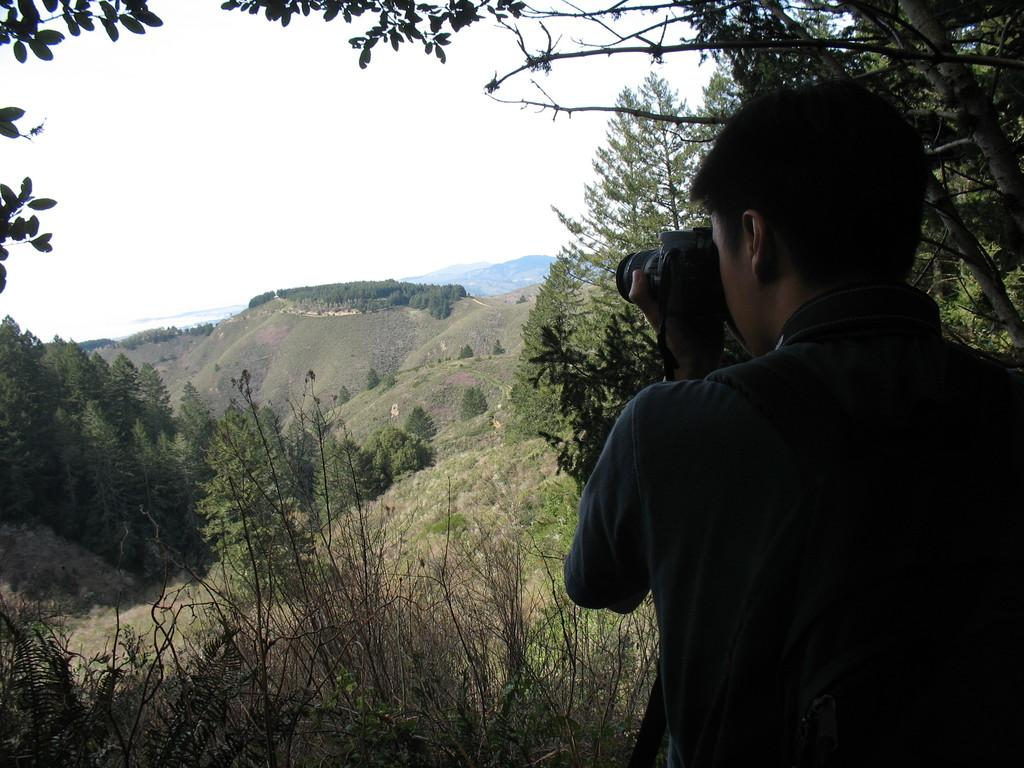Who is present in the image? There is a man in the image. What is the man holding in his hand? The man is holding a camera in his hand. What type of natural environment can be seen in the image? There are trees and mountains in the image. What is visible in the background of the image? The sky is visible in the background of the image. What type of scale is the man using to weigh the mountains in the image? There is no scale present in the image, and the man is not weighing the mountains. 